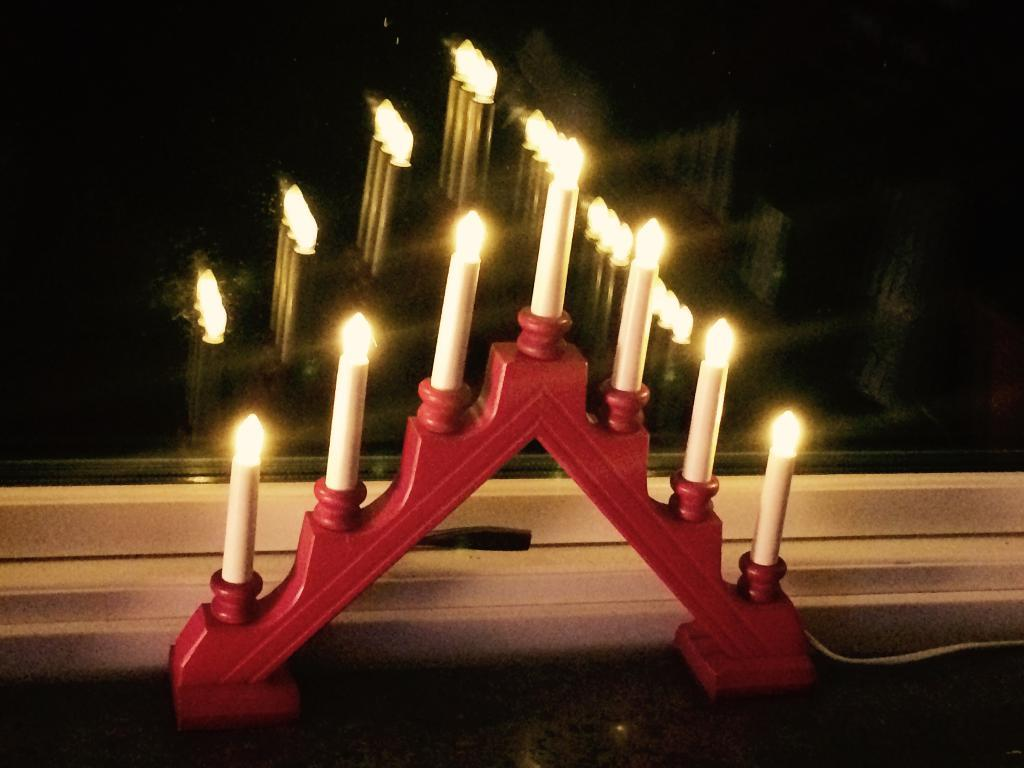What type of lighting is present in the image? There are candle lights in the image. What color is the wire that is visible in the image? The wire in the image is white. What is the color of the object to which the candle lights are attached? The object to which the candle lights are attached is red. How would you describe the overall lighting conditions in the image? The background of the image is dark. What type of stew is being prepared in the image? There is no stew present in the image; it features candle lights, a white wire, and a red object. Can you hear any rhythmic sounds in the image? There is no audible information in the image, so it is impossible to determine if there are any rhythmic sounds. 